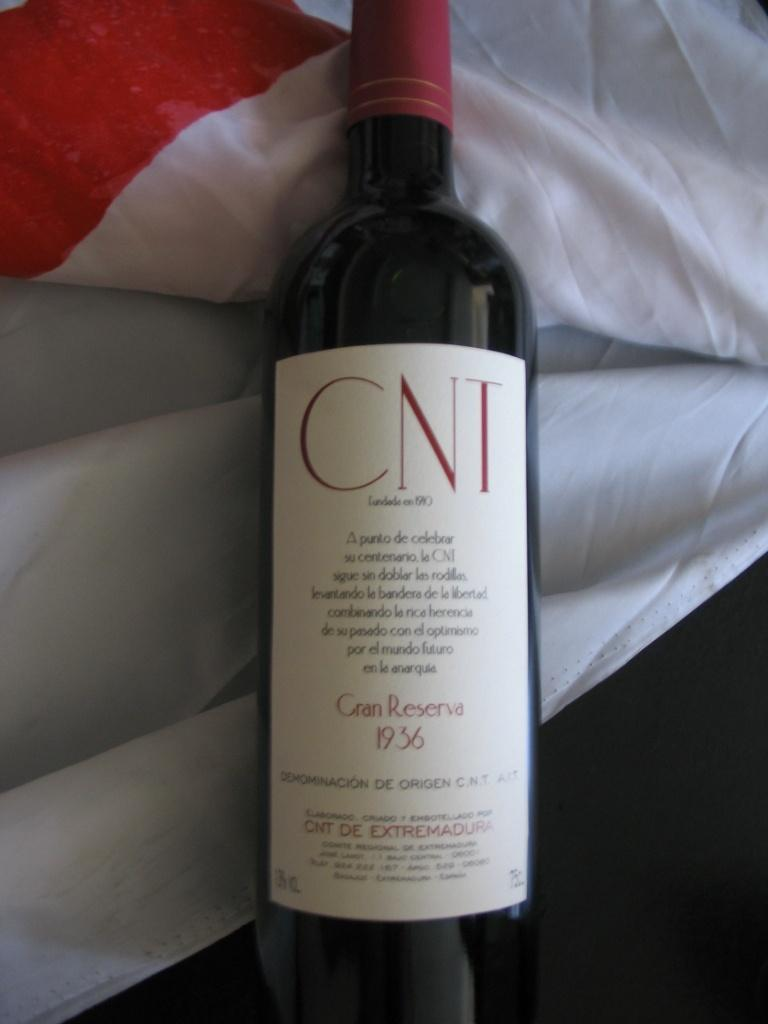<image>
Summarize the visual content of the image. A bottle of CNT wine from 1936 on top of a white sheet. 